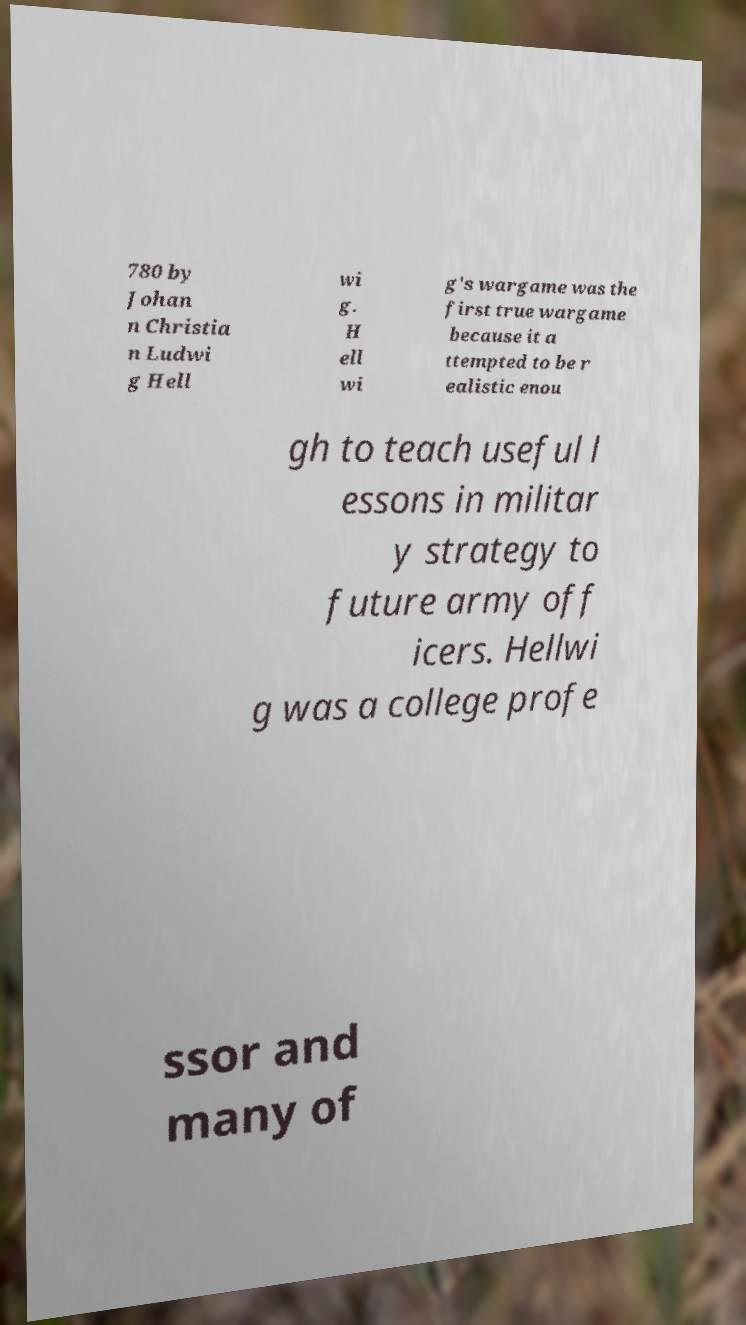There's text embedded in this image that I need extracted. Can you transcribe it verbatim? 780 by Johan n Christia n Ludwi g Hell wi g. H ell wi g's wargame was the first true wargame because it a ttempted to be r ealistic enou gh to teach useful l essons in militar y strategy to future army off icers. Hellwi g was a college profe ssor and many of 